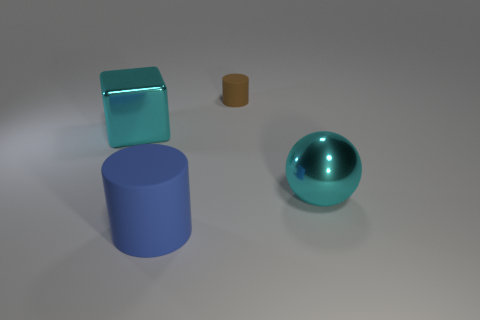What is the shape of the object that is the same color as the ball?
Your response must be concise. Cube. There is a rubber object on the left side of the tiny brown cylinder; does it have the same shape as the brown rubber thing?
Provide a succinct answer. Yes. What number of large cyan shiny blocks are in front of the cyan thing that is to the left of the shiny object that is in front of the big cyan block?
Offer a very short reply. 0. Are there fewer big cyan objects that are to the right of the metallic cube than big cyan shiny things in front of the small cylinder?
Your answer should be very brief. Yes. What color is the small rubber thing that is the same shape as the big blue object?
Ensure brevity in your answer.  Brown. How big is the cyan metallic ball?
Ensure brevity in your answer.  Large. What number of other purple shiny spheres have the same size as the metallic sphere?
Provide a short and direct response. 0. Does the metallic cube have the same color as the large metallic ball?
Offer a very short reply. Yes. Is the cylinder that is in front of the tiny rubber cylinder made of the same material as the cylinder that is behind the blue cylinder?
Make the answer very short. Yes. Are there more brown cylinders than tiny yellow metal balls?
Give a very brief answer. Yes. 